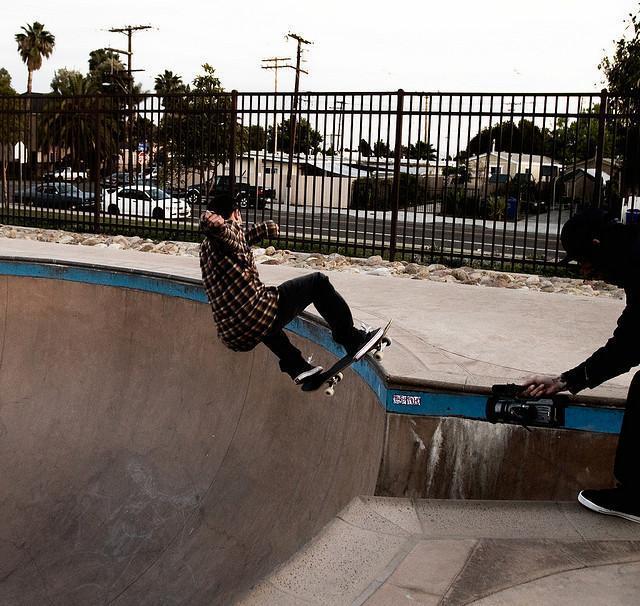How many people are there?
Give a very brief answer. 2. How many giraffes are in the scene?
Give a very brief answer. 0. 